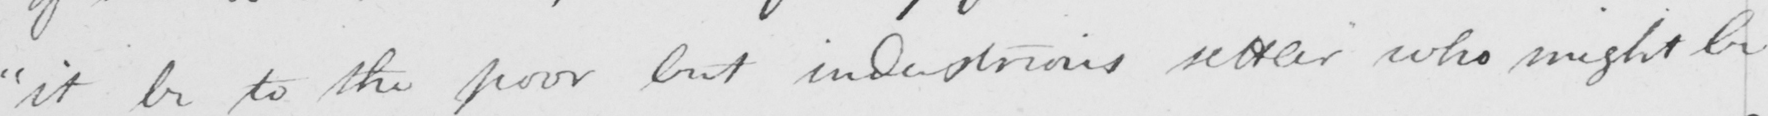Can you tell me what this handwritten text says? it be to the poor but industrious settler who might be 